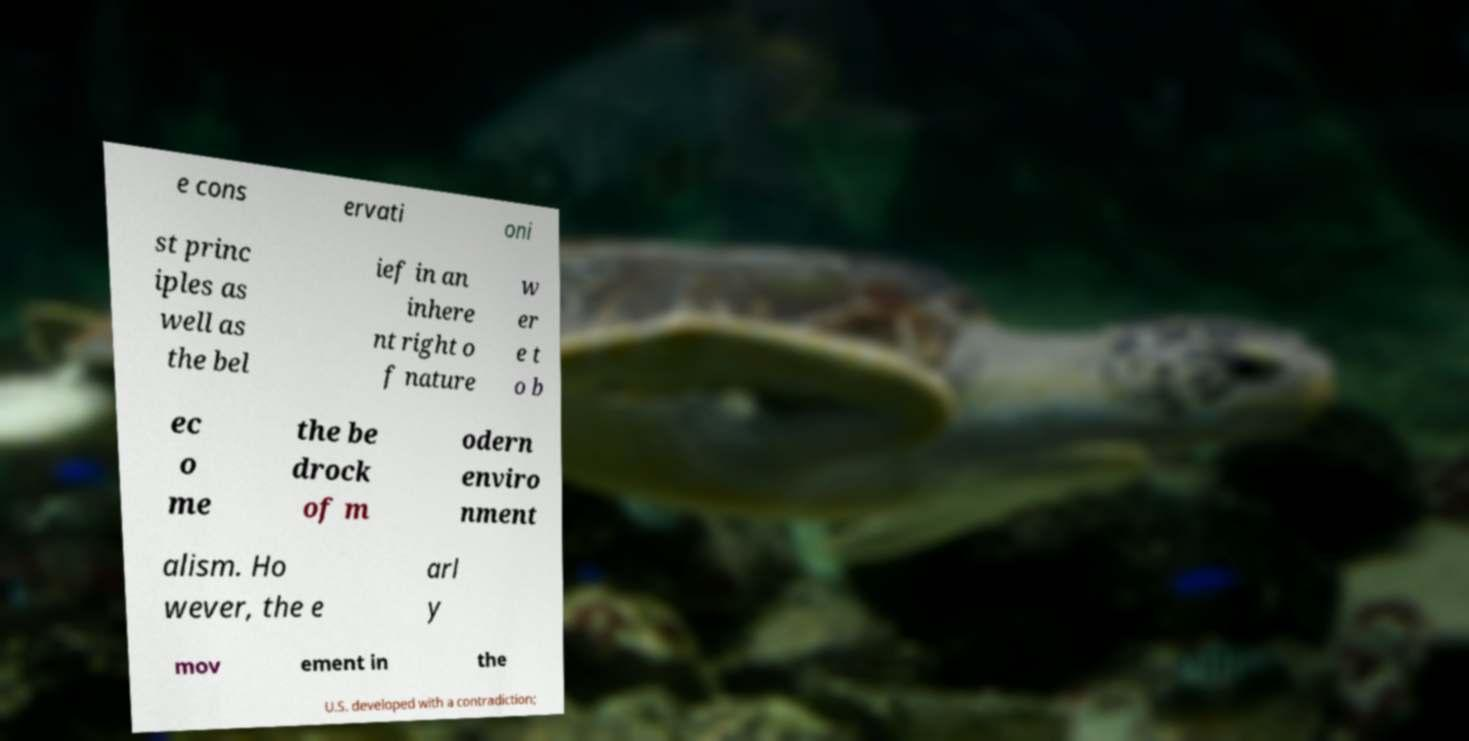Could you extract and type out the text from this image? e cons ervati oni st princ iples as well as the bel ief in an inhere nt right o f nature w er e t o b ec o me the be drock of m odern enviro nment alism. Ho wever, the e arl y mov ement in the U.S. developed with a contradiction; 